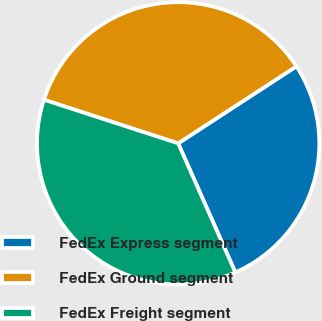Convert chart to OTSL. <chart><loc_0><loc_0><loc_500><loc_500><pie_chart><fcel>FedEx Express segment<fcel>FedEx Ground segment<fcel>FedEx Freight segment<nl><fcel>27.55%<fcel>35.81%<fcel>36.64%<nl></chart> 